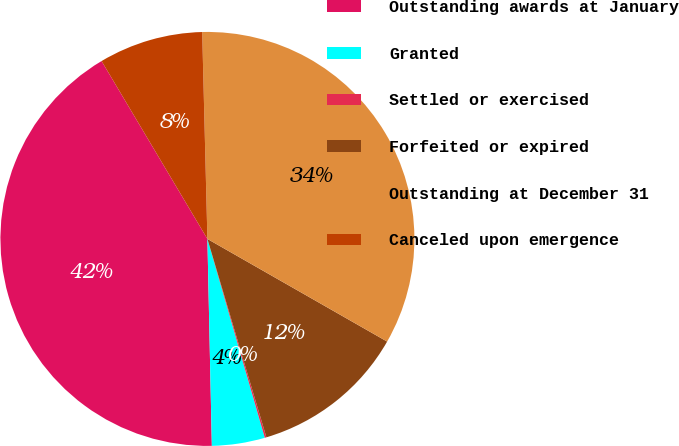Convert chart to OTSL. <chart><loc_0><loc_0><loc_500><loc_500><pie_chart><fcel>Outstanding awards at January<fcel>Granted<fcel>Settled or exercised<fcel>Forfeited or expired<fcel>Outstanding at December 31<fcel>Canceled upon emergence<nl><fcel>41.8%<fcel>4.13%<fcel>0.13%<fcel>12.14%<fcel>33.66%<fcel>8.14%<nl></chart> 